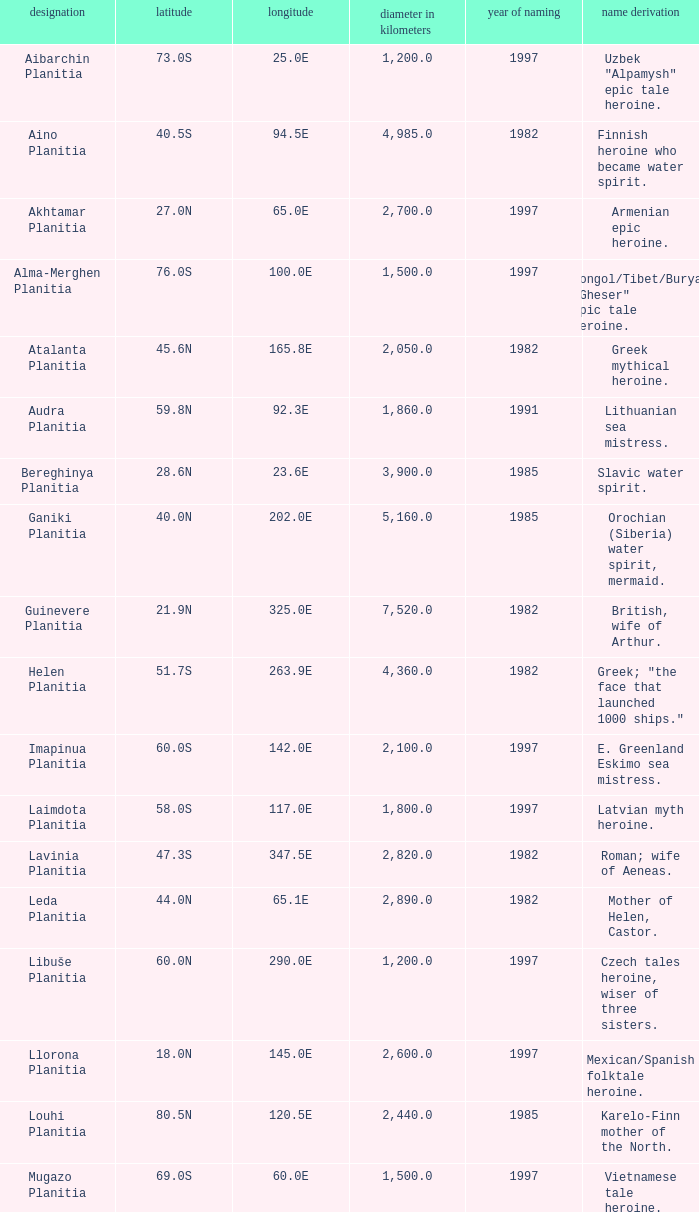Parse the table in full. {'header': ['designation', 'latitude', 'longitude', 'diameter in kilometers', 'year of naming', 'name derivation'], 'rows': [['Aibarchin Planitia', '73.0S', '25.0E', '1,200.0', '1997', 'Uzbek "Alpamysh" epic tale heroine.'], ['Aino Planitia', '40.5S', '94.5E', '4,985.0', '1982', 'Finnish heroine who became water spirit.'], ['Akhtamar Planitia', '27.0N', '65.0E', '2,700.0', '1997', 'Armenian epic heroine.'], ['Alma-Merghen Planitia', '76.0S', '100.0E', '1,500.0', '1997', 'Mongol/Tibet/Buryat "Gheser" epic tale heroine.'], ['Atalanta Planitia', '45.6N', '165.8E', '2,050.0', '1982', 'Greek mythical heroine.'], ['Audra Planitia', '59.8N', '92.3E', '1,860.0', '1991', 'Lithuanian sea mistress.'], ['Bereghinya Planitia', '28.6N', '23.6E', '3,900.0', '1985', 'Slavic water spirit.'], ['Ganiki Planitia', '40.0N', '202.0E', '5,160.0', '1985', 'Orochian (Siberia) water spirit, mermaid.'], ['Guinevere Planitia', '21.9N', '325.0E', '7,520.0', '1982', 'British, wife of Arthur.'], ['Helen Planitia', '51.7S', '263.9E', '4,360.0', '1982', 'Greek; "the face that launched 1000 ships."'], ['Imapinua Planitia', '60.0S', '142.0E', '2,100.0', '1997', 'E. Greenland Eskimo sea mistress.'], ['Laimdota Planitia', '58.0S', '117.0E', '1,800.0', '1997', 'Latvian myth heroine.'], ['Lavinia Planitia', '47.3S', '347.5E', '2,820.0', '1982', 'Roman; wife of Aeneas.'], ['Leda Planitia', '44.0N', '65.1E', '2,890.0', '1982', 'Mother of Helen, Castor.'], ['Libuše Planitia', '60.0N', '290.0E', '1,200.0', '1997', 'Czech tales heroine, wiser of three sisters.'], ['Llorona Planitia', '18.0N', '145.0E', '2,600.0', '1997', 'Mexican/Spanish folktale heroine.'], ['Louhi Planitia', '80.5N', '120.5E', '2,440.0', '1985', 'Karelo-Finn mother of the North.'], ['Mugazo Planitia', '69.0S', '60.0E', '1,500.0', '1997', 'Vietnamese tale heroine.'], ['Navka Planitia', '8.1S', '317.6E', '2,100.0', '1982', 'East-Slavic mermaid.'], ['Nsomeka Planitia', '53.0S', '195.0E', '2,100.0', '1994', 'Bantu culture heroine.'], ['Rusalka Planitia', '9.8N', '170.1E', '3,655.0', '1982', 'Russian mermaid.'], ['Sedna Planitia', '42.7N', '340.7E', '3,570.0', '1982', 'Eskimo; her fingers became seals and whales.'], ['Tahmina Planitia', '23.0S', '80.0E', '3,000.0', '1997', 'Iranian epic heroine, wife of knight Rustam.'], ['Tilli-Hanum Planitia', '54.0N', '120.0E', '2,300.0', '1997', 'Azeri "Ker-ogly" epic tale heroine.'], ['Tinatin Planitia', '15.0S', '15.0E', '0.0', '1994', 'Georgian epic heroine.'], ['Undine Planitia', '13.0N', '303.0E', '2,800.0', '1997', 'Lithuanian water nymph, mermaid.'], ['Vellamo Planitia', '45.4N', '149.1E', '2,155.0', '1985', 'Karelo-Finn mermaid.']]} What's the name origin of feature of diameter (km) 2,155.0 Karelo-Finn mermaid. 